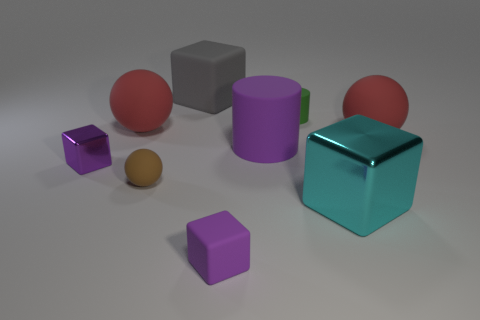Add 1 large yellow rubber objects. How many objects exist? 10 Subtract all large red spheres. How many spheres are left? 1 Subtract all cylinders. How many objects are left? 7 Subtract all brown balls. How many balls are left? 2 Subtract all green blocks. Subtract all brown spheres. How many blocks are left? 4 Subtract all red cylinders. How many green balls are left? 0 Subtract all small rubber things. Subtract all small matte cylinders. How many objects are left? 5 Add 4 small matte cubes. How many small matte cubes are left? 5 Add 4 small green matte objects. How many small green matte objects exist? 5 Subtract 0 yellow cubes. How many objects are left? 9 